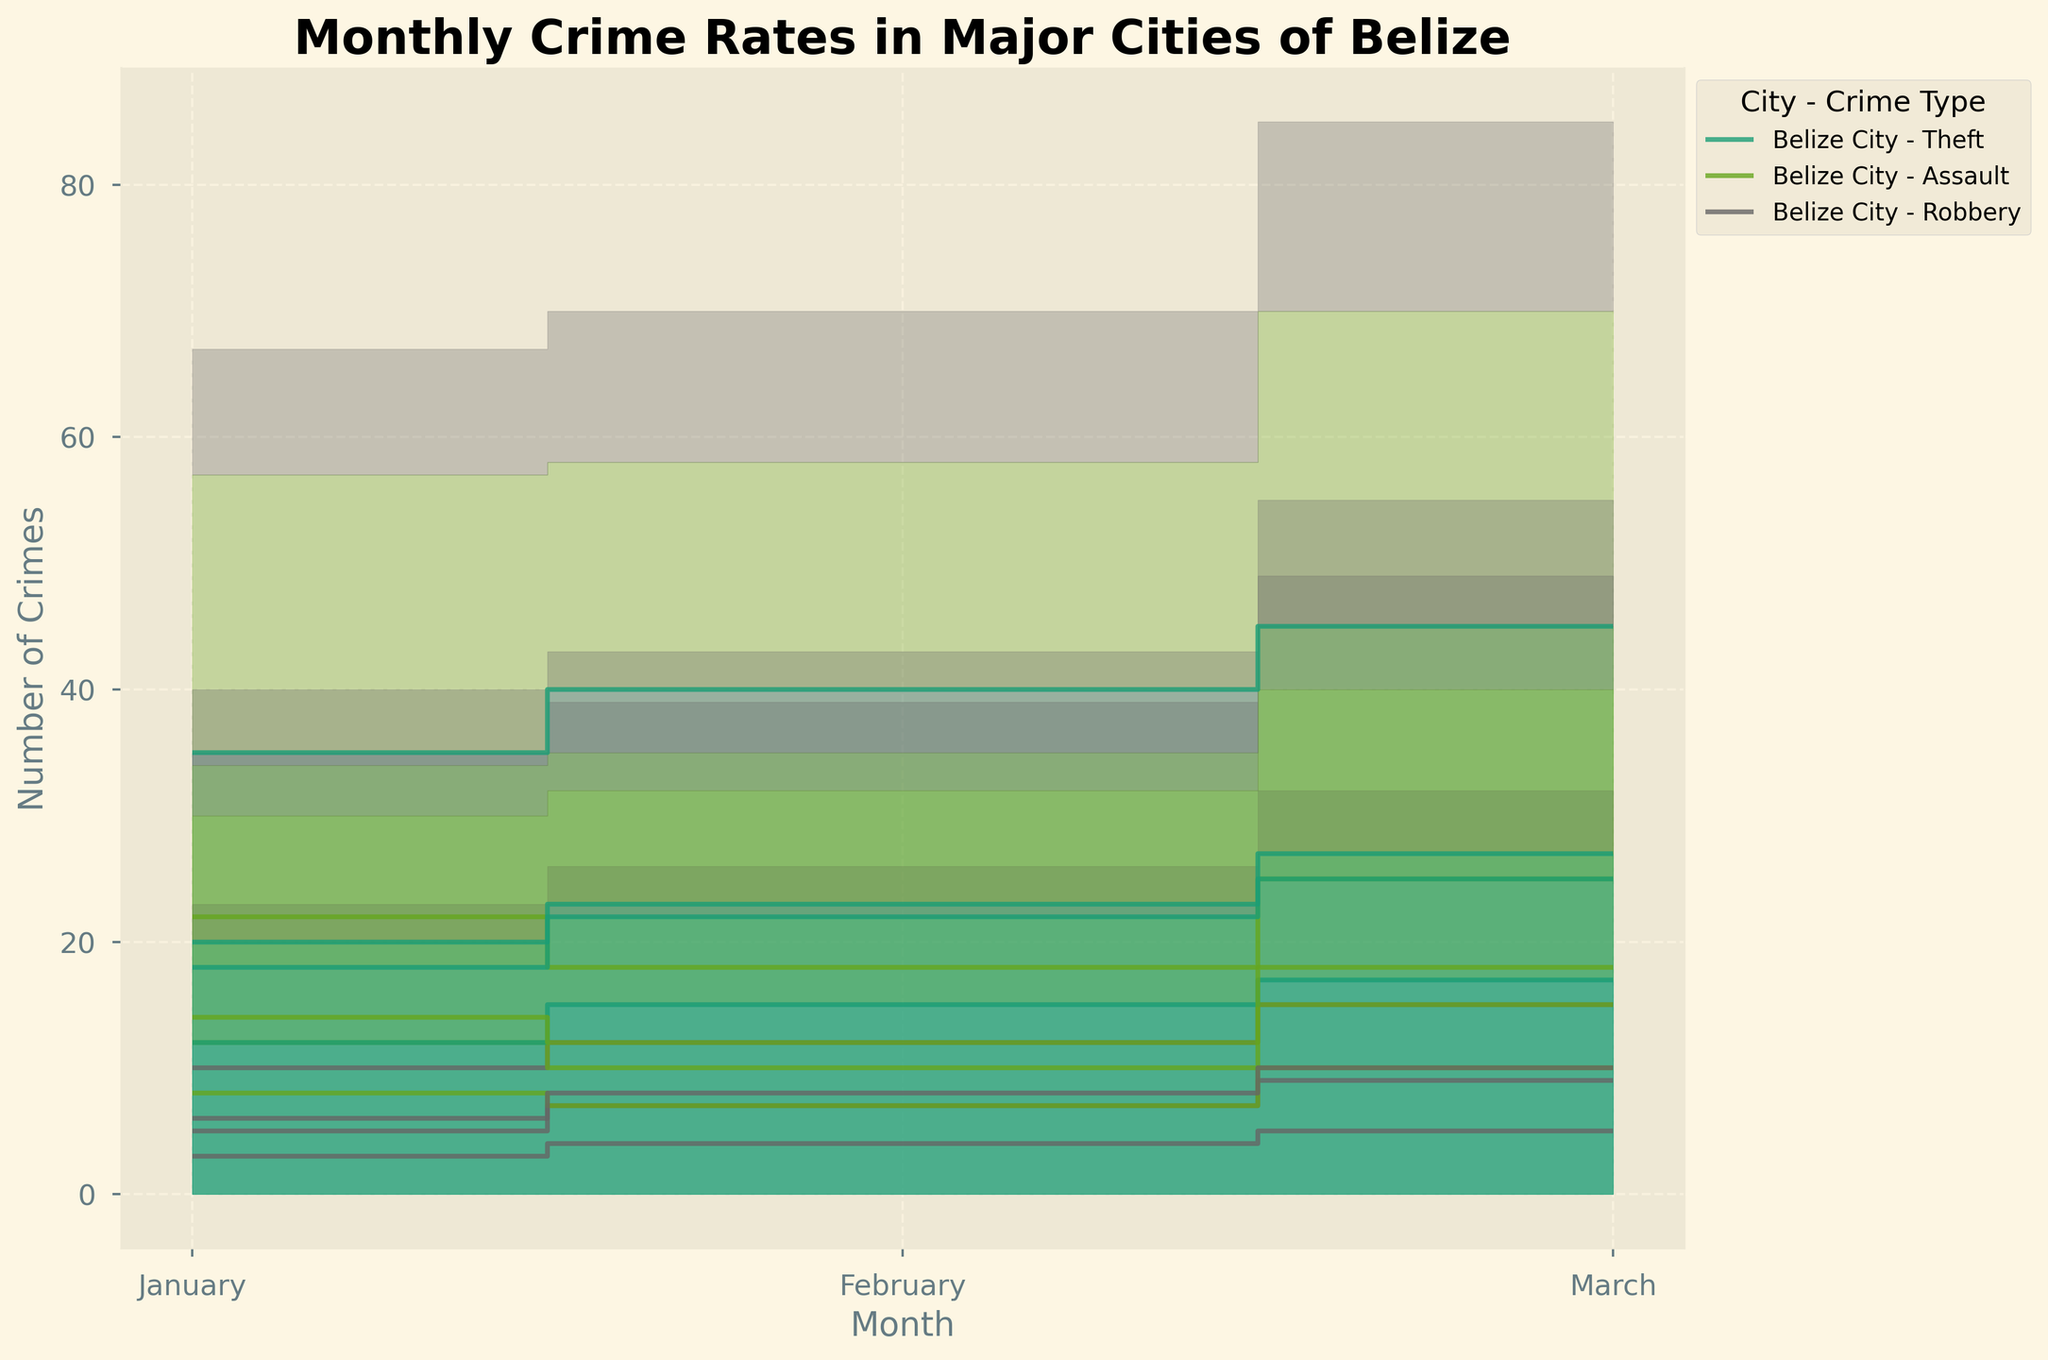What is the title of the chart? The title of the chart is usually located at the top and is intended to provide a summary of what the chart is about.
Answer: Monthly Crime Rates in Major Cities of Belize Which month had the highest total number of crimes in Belize City? Look for the stack height for each month in Belize City, which combines theft, assault, and robbery. Identify the month with the tallest stack.
Answer: March How does the number of theft incidents compare between Belize City and San Pedro in March? Identify the sections of the step area for March for both cities, focusing on the color designated for theft incidents (the bottommost section). Compare their heights.
Answer: Belize City has more theft incidents than San Pedro in March Which city had the highest number of robbery incidents in January? Analyze the robbery section (topmost colored section) for each city in January. Determine which city has the highest value.
Answer: Belize City What is the total number of assault incidents in Belmopan across all months? Sum the number of assault incidents in Belmopan for January, February, and March.
Answer: 37 Are there any months where the number of assault incidents in Orange Walk is higher than in San Pedro? Compare the heights of the sections representing assault incidents (middle colored section) for each month between Orange Walk and San Pedro.
Answer: No, in each month San Pedro has more assault incidents than Orange Walk What color represents the robbery incidents in the chart? Each type of crime has a distinct color in the step area chart. Identify the topmost section's color throughout the chart, as this represents robbery incidents.
Answer: Likely a distinct dark color (depending on the specific color scheme from plt.cm.Dark2) How does the trend in the number of crimes in Belmopan change from January to March? Observe the heights of the stacked sections for Belmopan across the months. Indicate whether the numbers are increasing, decreasing, or stable.
Answer: Increasing In which month did Orange Walk have the highest combined number of theft and assault incidents? Sum the heights of the theft and assault sections for each month in Orange Walk and identify the month with the maximum value.
Answer: March Compare the overall crime rates of San Pedro and Belmopan in February. Which city had a higher rate? Sum the heights of all crime sections for San Pedro and Belmopan in February to determine which is taller.
Answer: San Pedro 